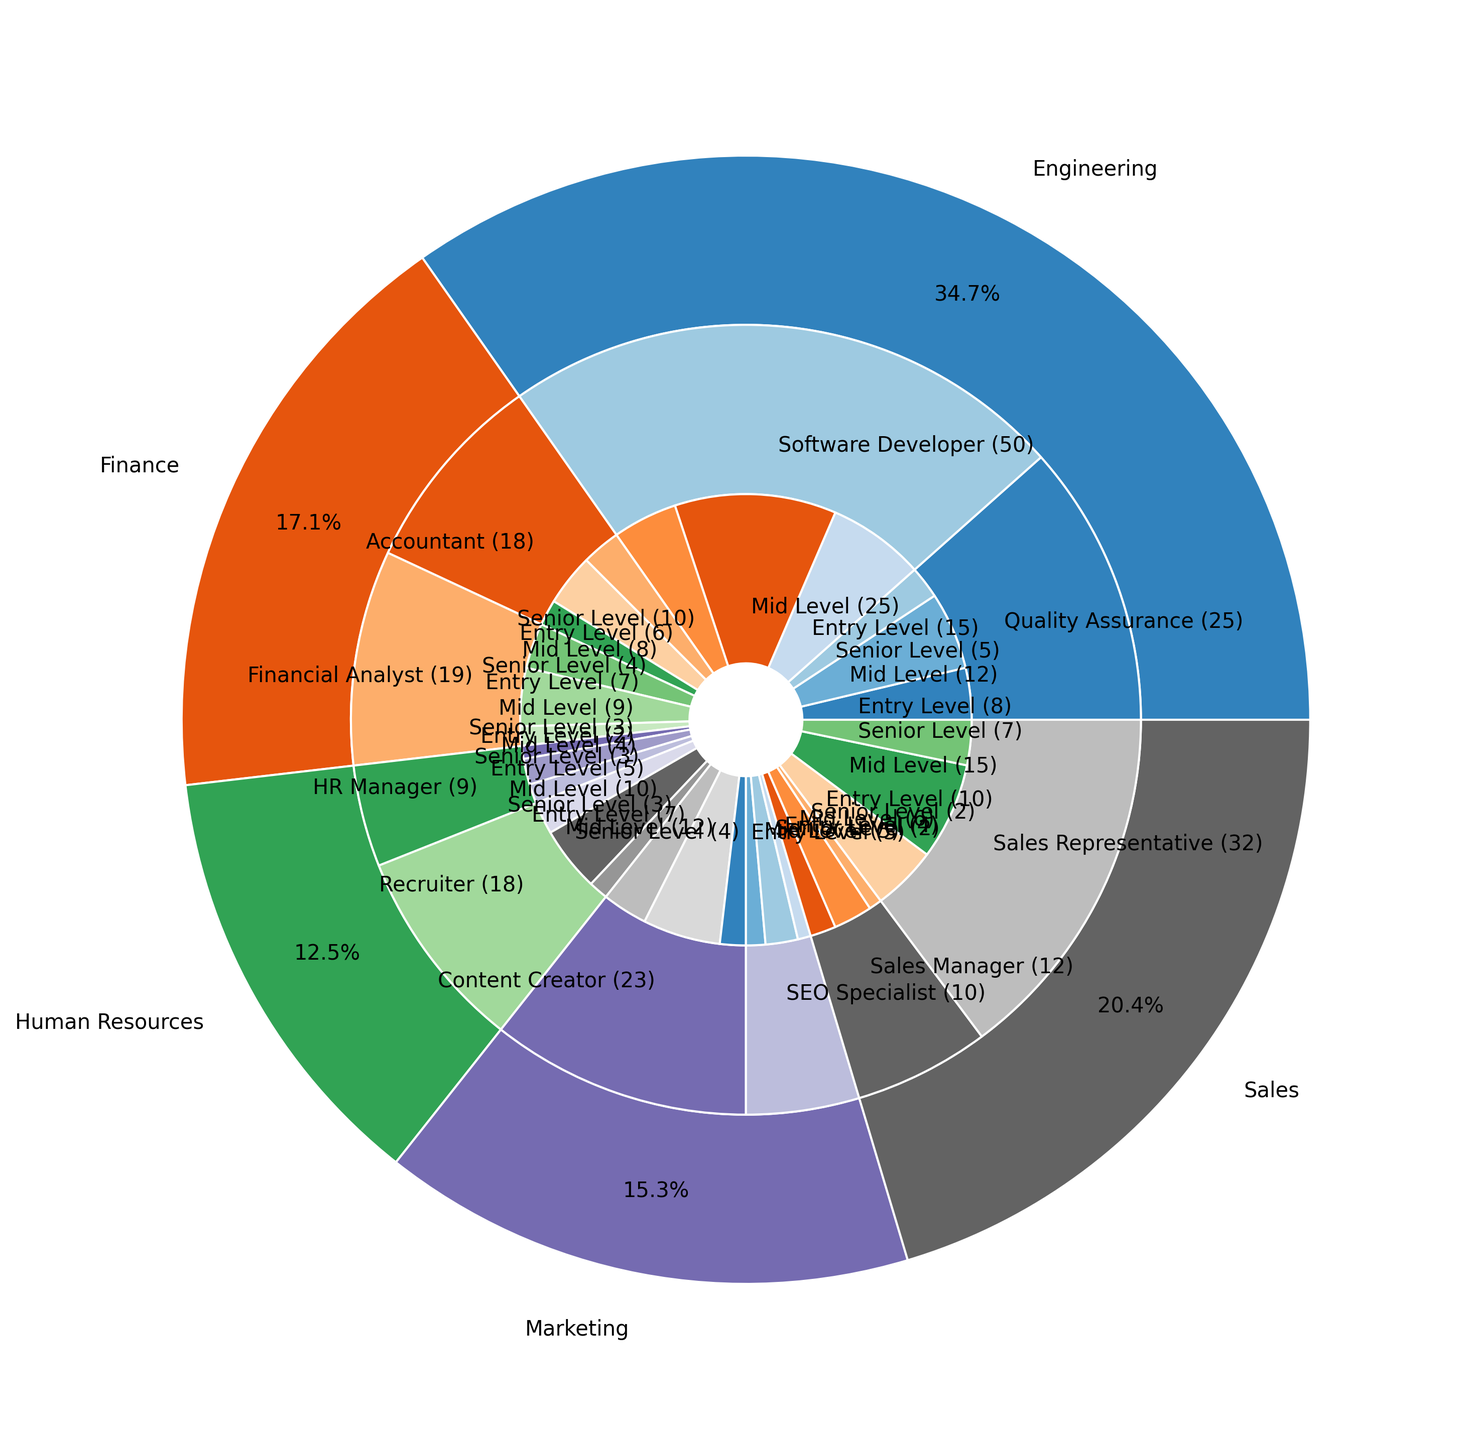Which department has the highest number of employees? Look at the outer ring of the pie chart. Compare the sizes of the slices that represent each department. Identify the largest slice to determine the department with the highest number of employees.
Answer: Engineering Which role type within the Sales department has the highest number of employees? Focus on the Sales section of the middle ring. Compare the sizes of the slices for 'Sales Representative' and 'Sales Manager'. The larger slice represents the role type with the highest number of employees.
Answer: Sales Representative What percentage of the Finance department's employees are Financial Analysts? Look at the Finance section in the middle ring, identifying the slice for 'Financial Analyst'. Calculate the percentage as (number of Financial Analysts / total number of Finance employees) * 100.
Answer: 55.2% What's the difference in the number of mid-level employees between Engineering and Marketing? Sum the mid-level employees in Engineering and Marketing from their respective sections in the innermost ring. Subtract the total number of Marketing mid-level employees from the total number in Engineering.
Answer: 16 Which department has the least number of senior-level employees? Look at the innermost ring. Compare the slices representing senior-level employees across departments. Identify the smallest slice to find the department with the least number of senior-level employees.
Answer: Human Resources Which role type in the Engineering department has the fewest employees? Focus on the Engineering section of the middle ring. Compare the sizes of the slices for 'Software Developer' and 'Quality Assurance'. Identify the smallest slice to determine the role type with the fewest employees.
Answer: Quality Assurance How many more entry-level employees are in Sales compared to Marketing? Sum the entry-level employees for Sales and Marketing from their respective sections in the ring. Subtract the number of Marketing entry-level employees from the total number in Sales.
Answer: 4 What is the total number of employees with senior-level experience across all departments? Sum the number of senior-level employees from each department by adding the values from the innermost ring.
Answer: 36 